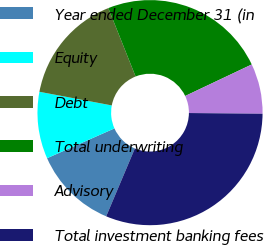Convert chart. <chart><loc_0><loc_0><loc_500><loc_500><pie_chart><fcel>Year ended December 31 (in<fcel>Equity<fcel>Debt<fcel>Total underwriting<fcel>Advisory<fcel>Total investment banking fees<nl><fcel>12.0%<fcel>9.6%<fcel>15.99%<fcel>24.0%<fcel>7.2%<fcel>31.2%<nl></chart> 